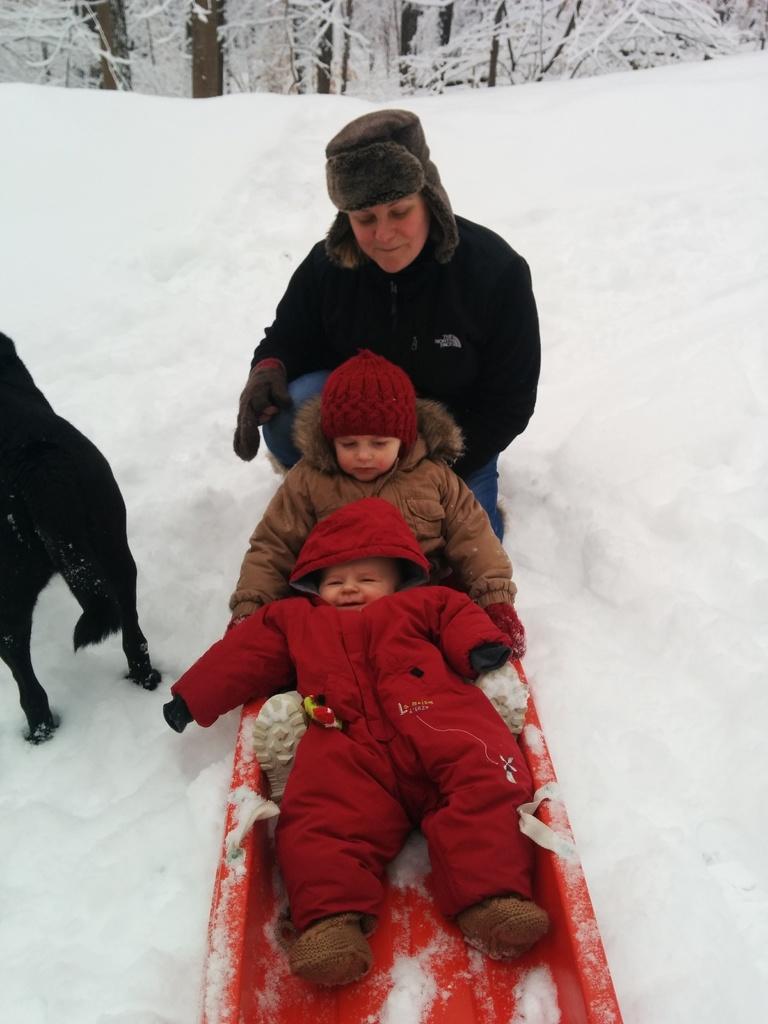In one or two sentences, can you explain what this image depicts? In this picture there are two persons sitting and there is a person on knee and there is a dog standing. At the back there are trees. At the bottom there is snow. 